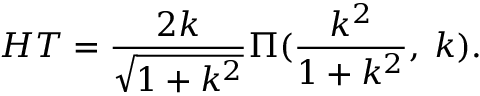<formula> <loc_0><loc_0><loc_500><loc_500>H T = \frac { 2 k } { \sqrt { 1 + k ^ { 2 } } } \Pi ( \frac { k ^ { 2 } } { 1 + k ^ { 2 } } , \, k ) .</formula> 